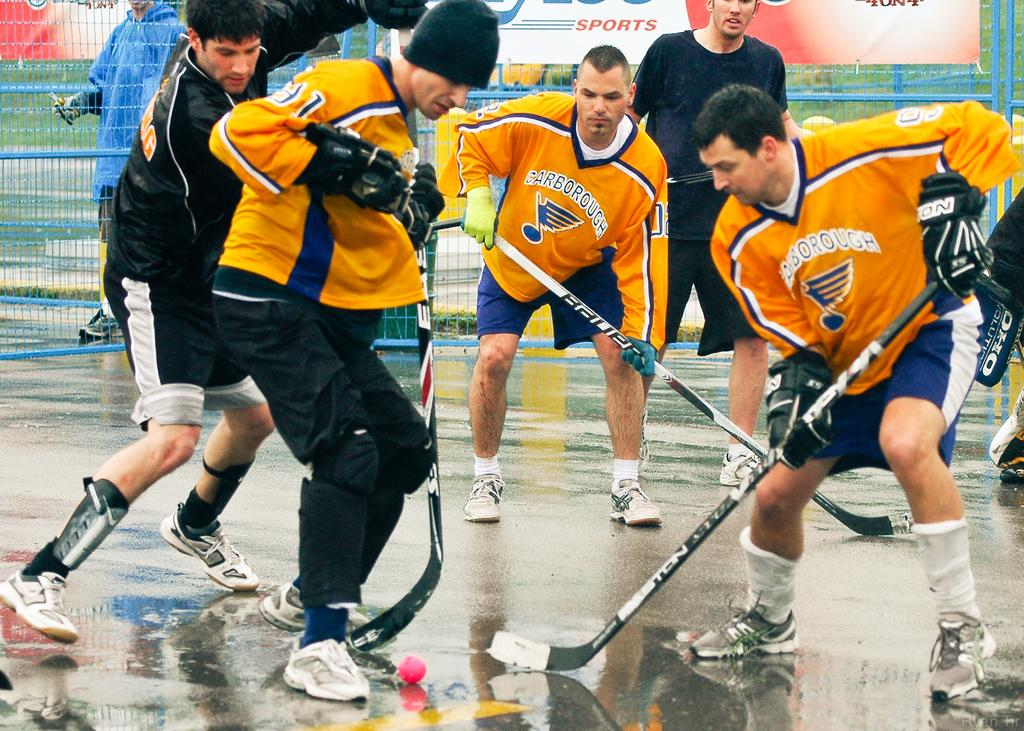Provide a one-sentence caption for the provided image. Hockey players with orange jerseys from the school carborough. 